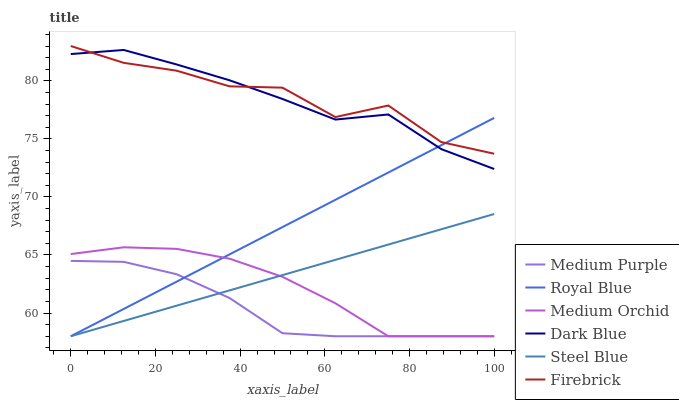Does Medium Purple have the minimum area under the curve?
Answer yes or no. Yes. Does Firebrick have the maximum area under the curve?
Answer yes or no. Yes. Does Medium Orchid have the minimum area under the curve?
Answer yes or no. No. Does Medium Orchid have the maximum area under the curve?
Answer yes or no. No. Is Steel Blue the smoothest?
Answer yes or no. Yes. Is Firebrick the roughest?
Answer yes or no. Yes. Is Medium Orchid the smoothest?
Answer yes or no. No. Is Medium Orchid the roughest?
Answer yes or no. No. Does Medium Orchid have the lowest value?
Answer yes or no. Yes. Does Firebrick have the lowest value?
Answer yes or no. No. Does Firebrick have the highest value?
Answer yes or no. Yes. Does Medium Orchid have the highest value?
Answer yes or no. No. Is Medium Orchid less than Dark Blue?
Answer yes or no. Yes. Is Dark Blue greater than Steel Blue?
Answer yes or no. Yes. Does Royal Blue intersect Medium Purple?
Answer yes or no. Yes. Is Royal Blue less than Medium Purple?
Answer yes or no. No. Is Royal Blue greater than Medium Purple?
Answer yes or no. No. Does Medium Orchid intersect Dark Blue?
Answer yes or no. No. 